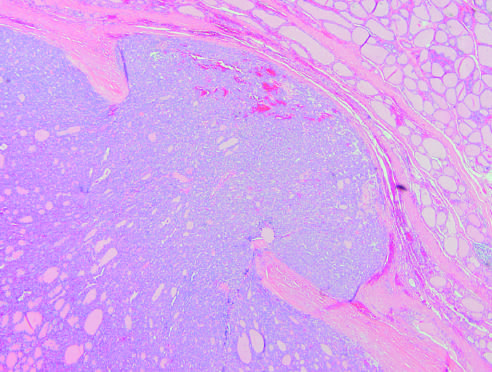do iron deposits shown by a special staining process demonstrate capsular invasion that may be minimal, as in this case, or widespread, with extension into local structures of the neck by contrast?
Answer the question using a single word or phrase. No 